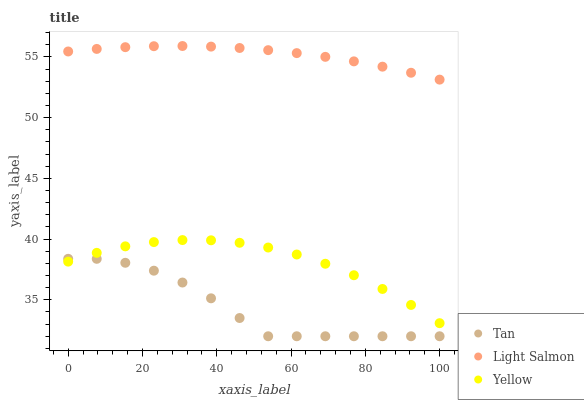Does Tan have the minimum area under the curve?
Answer yes or no. Yes. Does Light Salmon have the maximum area under the curve?
Answer yes or no. Yes. Does Yellow have the minimum area under the curve?
Answer yes or no. No. Does Yellow have the maximum area under the curve?
Answer yes or no. No. Is Light Salmon the smoothest?
Answer yes or no. Yes. Is Tan the roughest?
Answer yes or no. Yes. Is Yellow the smoothest?
Answer yes or no. No. Is Yellow the roughest?
Answer yes or no. No. Does Tan have the lowest value?
Answer yes or no. Yes. Does Yellow have the lowest value?
Answer yes or no. No. Does Light Salmon have the highest value?
Answer yes or no. Yes. Does Yellow have the highest value?
Answer yes or no. No. Is Yellow less than Light Salmon?
Answer yes or no. Yes. Is Light Salmon greater than Tan?
Answer yes or no. Yes. Does Tan intersect Yellow?
Answer yes or no. Yes. Is Tan less than Yellow?
Answer yes or no. No. Is Tan greater than Yellow?
Answer yes or no. No. Does Yellow intersect Light Salmon?
Answer yes or no. No. 